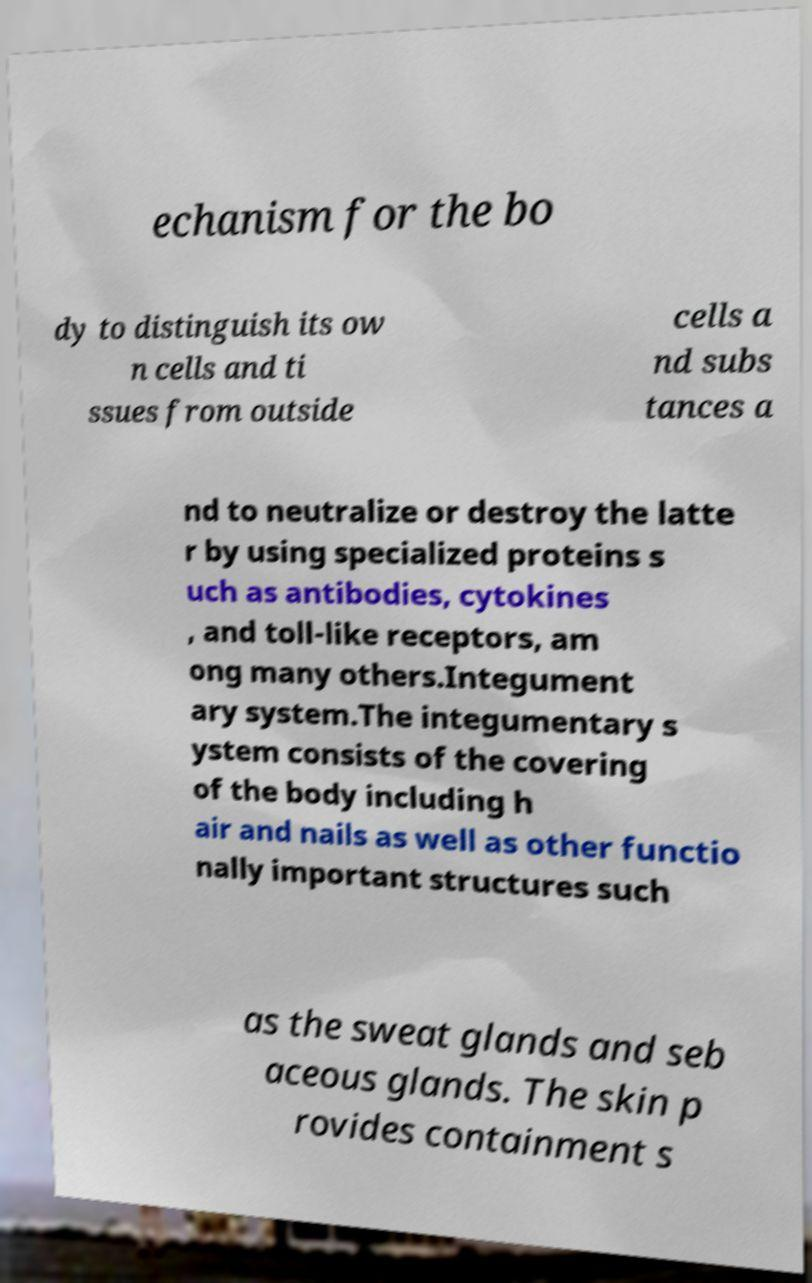For documentation purposes, I need the text within this image transcribed. Could you provide that? echanism for the bo dy to distinguish its ow n cells and ti ssues from outside cells a nd subs tances a nd to neutralize or destroy the latte r by using specialized proteins s uch as antibodies, cytokines , and toll-like receptors, am ong many others.Integument ary system.The integumentary s ystem consists of the covering of the body including h air and nails as well as other functio nally important structures such as the sweat glands and seb aceous glands. The skin p rovides containment s 